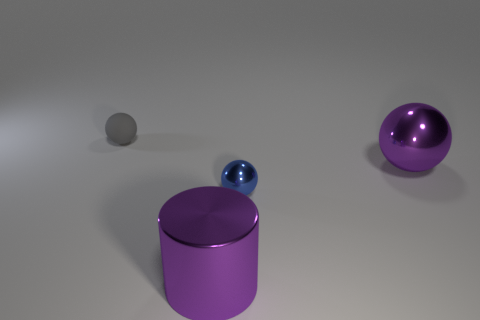How many other things are there of the same shape as the small gray rubber object?
Provide a succinct answer. 2. The metal sphere in front of the large metallic object that is behind the purple metallic cylinder is what color?
Your answer should be very brief. Blue. What size is the other matte object that is the same shape as the small blue object?
Your response must be concise. Small. Do the rubber object and the large metallic cylinder have the same color?
Provide a short and direct response. No. How many purple objects are left of the purple metallic thing that is in front of the tiny thing in front of the small gray ball?
Offer a terse response. 0. Is the number of small metallic spheres greater than the number of large red metallic objects?
Keep it short and to the point. Yes. How many large purple objects are there?
Offer a very short reply. 2. There is a large purple thing that is to the left of the big object that is right of the small thing in front of the small gray rubber object; what is its shape?
Your answer should be very brief. Cylinder. Is the number of big purple shiny cylinders right of the purple cylinder less than the number of objects that are in front of the small rubber object?
Offer a very short reply. Yes. Is the shape of the small object that is in front of the small matte thing the same as the thing to the right of the blue metal object?
Keep it short and to the point. Yes. 